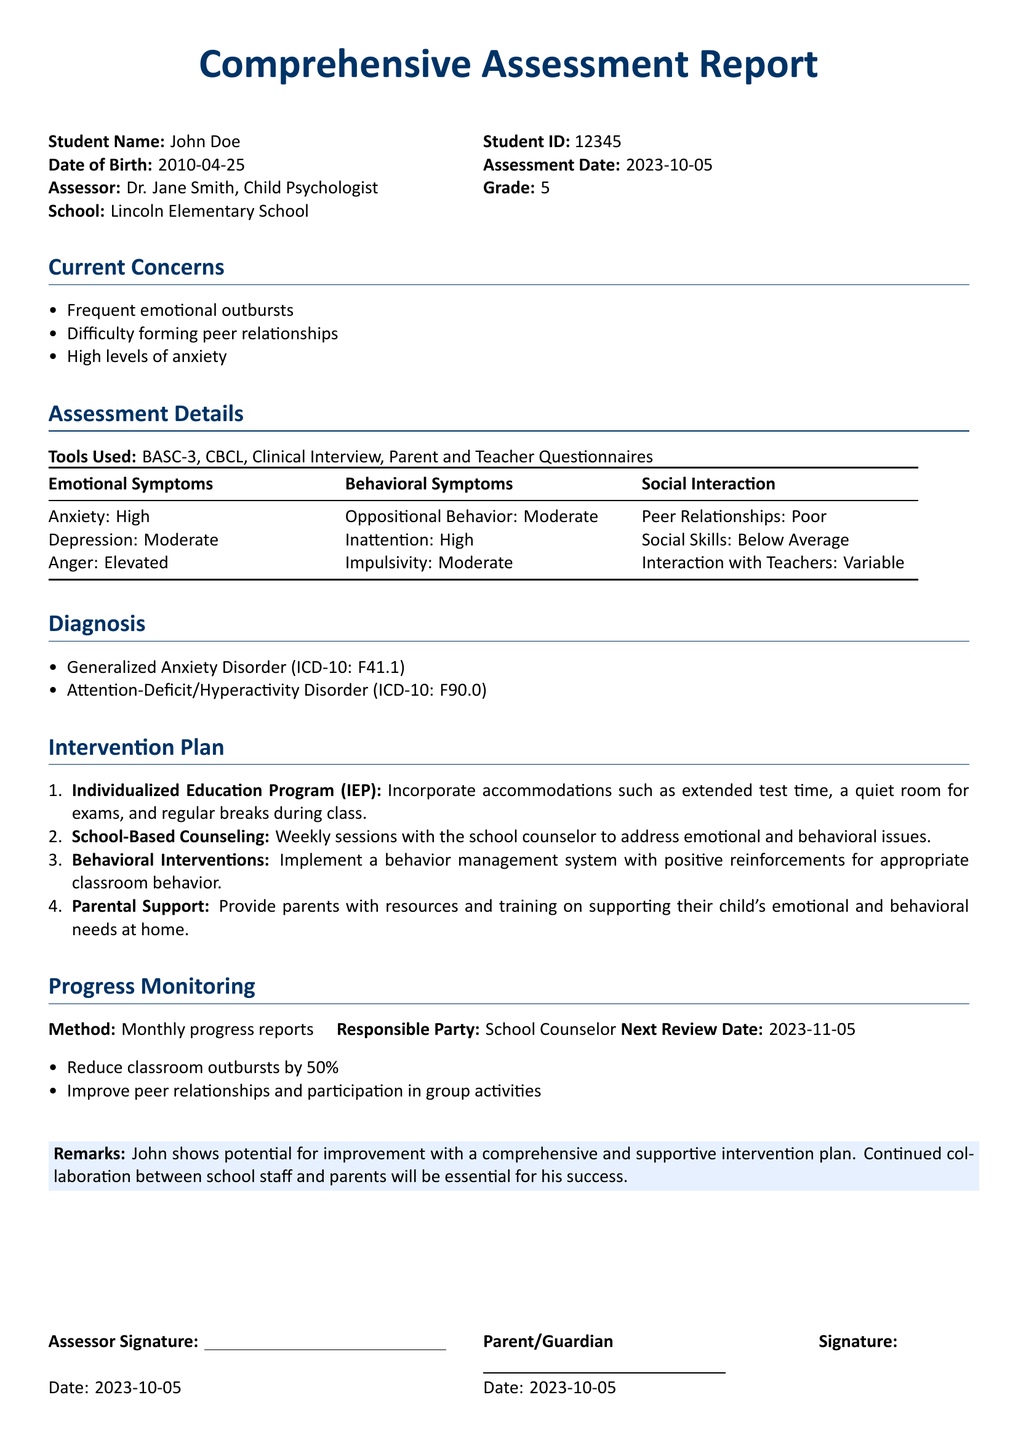What is the student's name? The student's name is listed in the document under the student details section.
Answer: John Doe What is the date of assessment? The date of assessment is specified in the document.
Answer: 2023-10-05 What is the student's ID? The student's ID is mentioned in the header of the document.
Answer: 12345 What are the emotional symptoms identified? The emotional symptoms are detailed in the assessment details section.
Answer: Anxiety: High, Depression: Moderate, Anger: Elevated What is the diagnosis given to the student? The diagnosis can be found in the diagnosis section of the document.
Answer: Generalized Anxiety Disorder What intervention is proposed to improve peer relationships? The intervention plans include specific strategies to assist with peer relationships.
Answer: Improve peer relationships and participation in group activities Who is responsible for progress monitoring? The responsible party for progress monitoring is stated in the progress monitoring section.
Answer: School Counselor When is the next review date scheduled? The next review date is noted in the progress monitoring section of the document.
Answer: 2023-11-05 What tools were used for assessment? The tools used for assessment are listed in the assessment details section.
Answer: BASC-3, CBCL, Clinical Interview, Parent and Teacher Questionnaires 